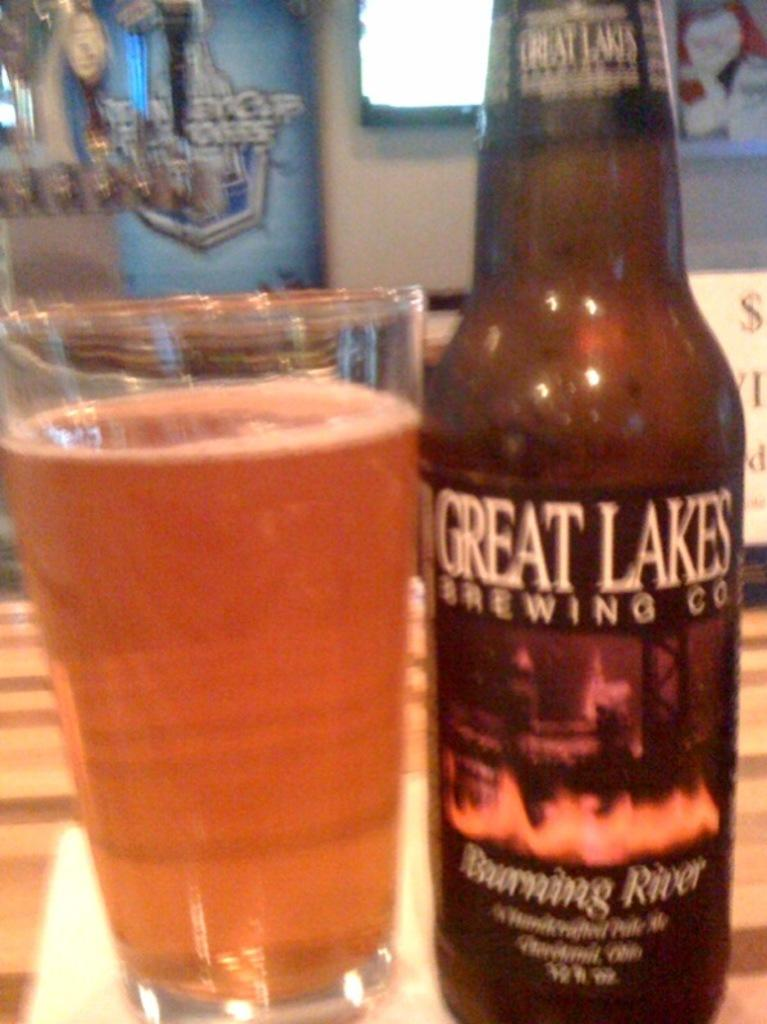Provide a one-sentence caption for the provided image. A bottle and glass of Great Lakes Brewing Co beer. 